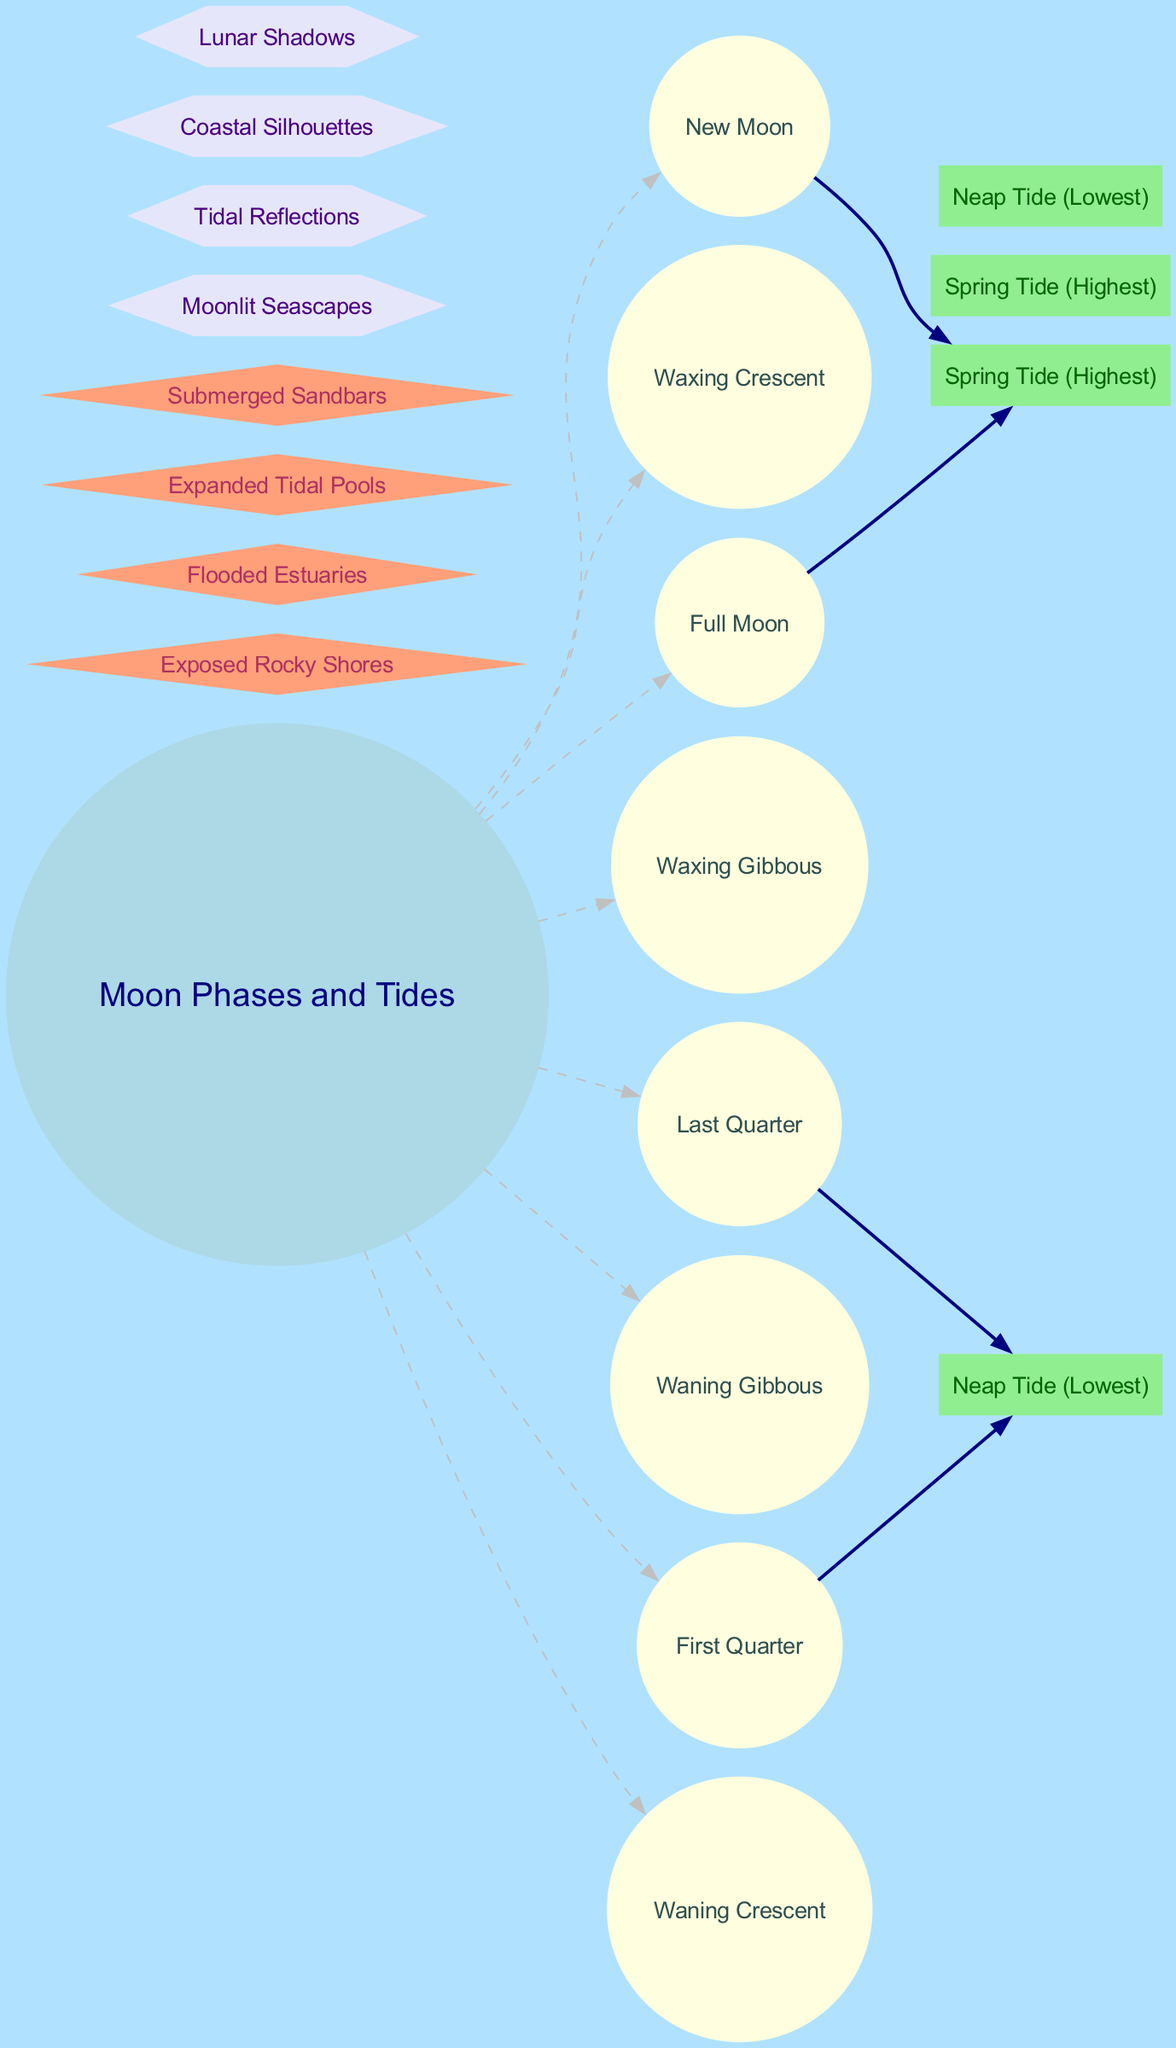What are the eight phases of the Moon? The diagram lists the eight phases of the Moon, which are New Moon, Waxing Crescent, First Quarter, Waxing Gibbous, Full Moon, Waning Gibbous, Last Quarter, and Waning Crescent.
Answer: New Moon, Waxing Crescent, First Quarter, Waxing Gibbous, Full Moon, Waning Gibbous, Last Quarter, Waning Crescent Which phase of the Moon causes the highest tidal effect? The diagram indicates that both the New Moon and Full Moon phases result in a Spring Tide, which is the highest tidal effect.
Answer: New Moon and Full Moon How many tidal effects are shown in the diagram? The diagram displays four tidal effects: Spring Tide (Highest), Neap Tide (Lowest), Spring Tide (Highest), and Neap Tide (Lowest), thus indicating a total of four tidal effects.
Answer: 4 What is the coastal impact during the Full Moon? The diagram shows that during a Full Moon phase, the associated tidal effect is a Spring Tide, which implies potential coastal impacts like Flooded Estuaries or Exposed Rocky Shores. However, the diagram specifically identifies Flooded Estuaries for high tides.
Answer: Flooded Estuaries Identify one artistic inspiration associated with the tidal effects. The diagram connects various artistic inspirations derived from the tidal effects, including Moonlit Seascapes, Tidal Reflections, Coastal Silhouettes, and Lunar Shadows. Thus, any of these can be identified as inspiration.
Answer: Moonlit Seascapes During which Moon phases do Neap Tides occur? According to the diagram, Neap Tides occur during the First Quarter and Last Quarter phases of the Moon.
Answer: First Quarter and Last Quarter What shape are the nodes that represent tidal effects? The nodes representing tidal effects are indicated in the diagram to be shaped as boxes, with their color set to light green.
Answer: Box How are the Moon phases connected to tidal effects in the diagram? The connections in the diagram show that the New Moon and Full Moon phases link to Spring Tide (Highest), while First Quarter and Last Quarter phases connect to Neap Tide (Lowest), indicating the relationship between lunar phases and tidal changes.
Answer: New Moon and Full Moon connect to Spring Tide; First Quarter and Last Quarter to Neap Tide 